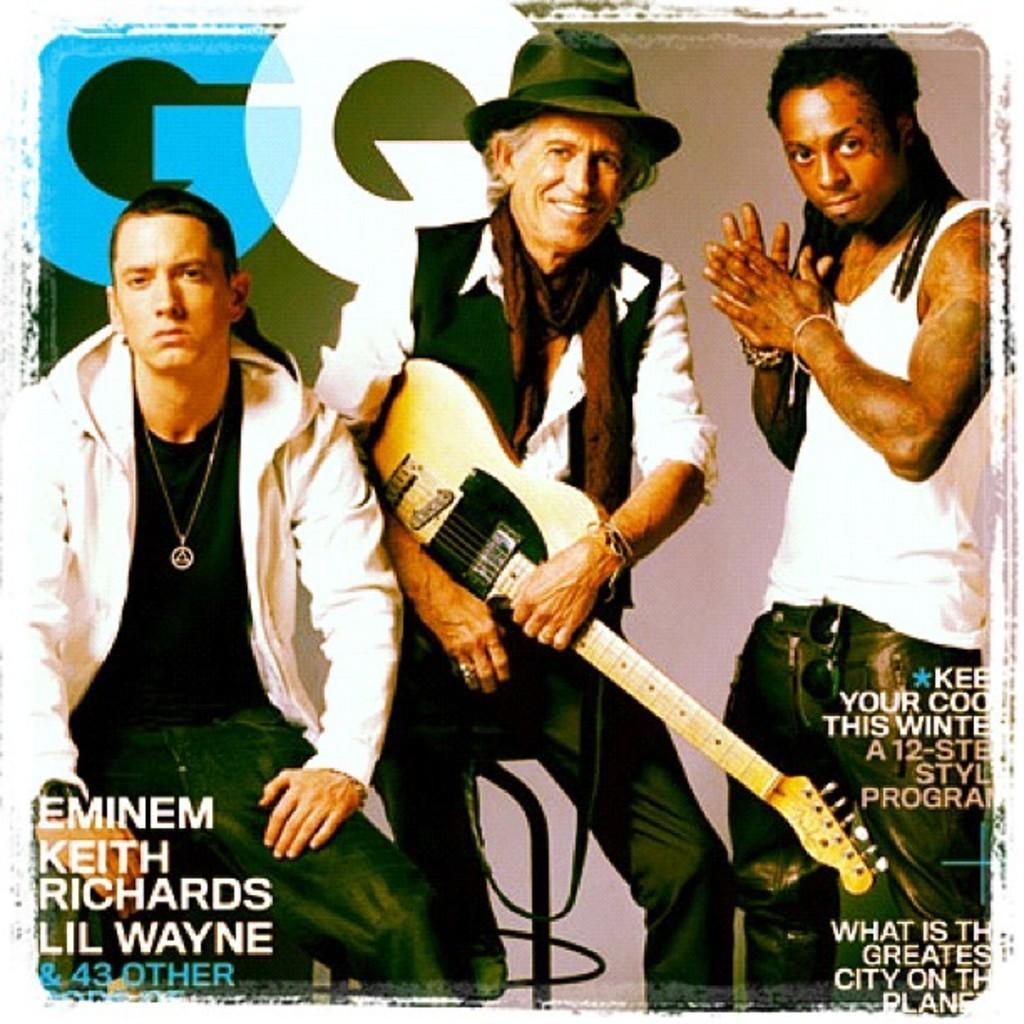Please provide a concise description of this image. This picture is an magazine poster and we see three men two are seated and one person is standing the second one is holding a guitar in his hand. 